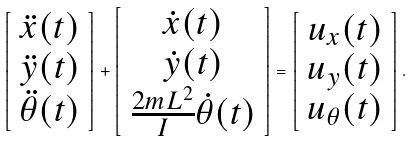<formula> <loc_0><loc_0><loc_500><loc_500>\left [ \begin{array} { c } \ddot { x } ( t ) \\ \ddot { y } ( t ) \\ \ddot { \theta } ( t ) \end{array} \right ] + \left [ \begin{array} { c } \dot { x } ( t ) \\ \dot { y } ( t ) \\ \frac { 2 m L ^ { 2 } } { I } \dot { \theta } ( t ) \end{array} \right ] = \left [ \begin{array} { c } u _ { x } ( t ) \\ u _ { y } ( t ) \\ u _ { \theta } ( t ) \end{array} \right ] .</formula> 